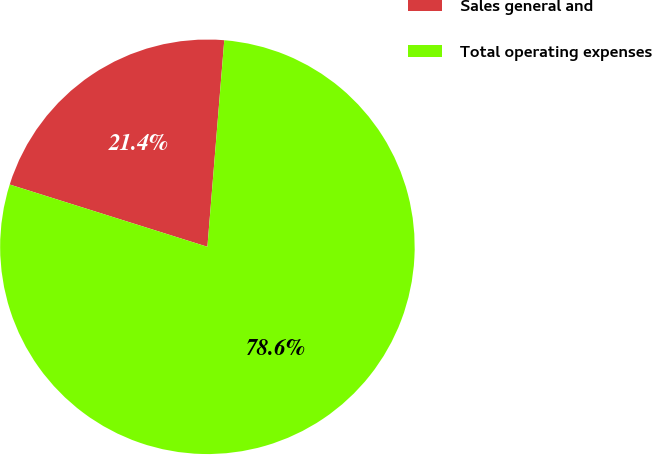Convert chart to OTSL. <chart><loc_0><loc_0><loc_500><loc_500><pie_chart><fcel>Sales general and<fcel>Total operating expenses<nl><fcel>21.44%<fcel>78.56%<nl></chart> 